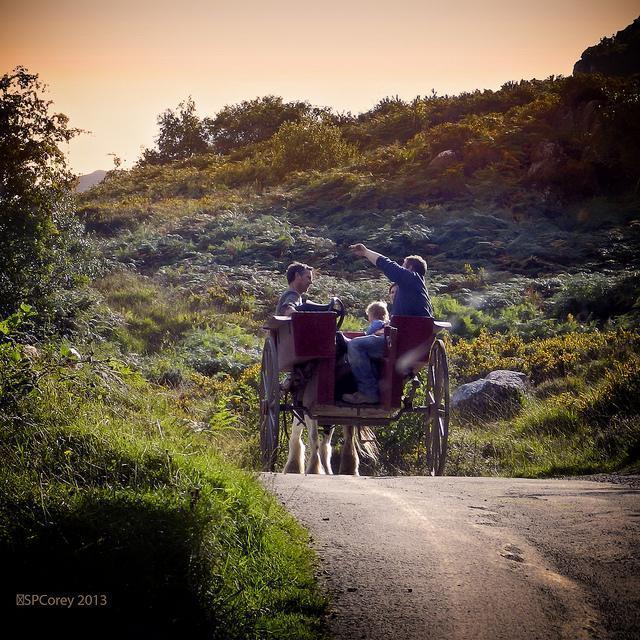How many buses are there?
Give a very brief answer. 0. 